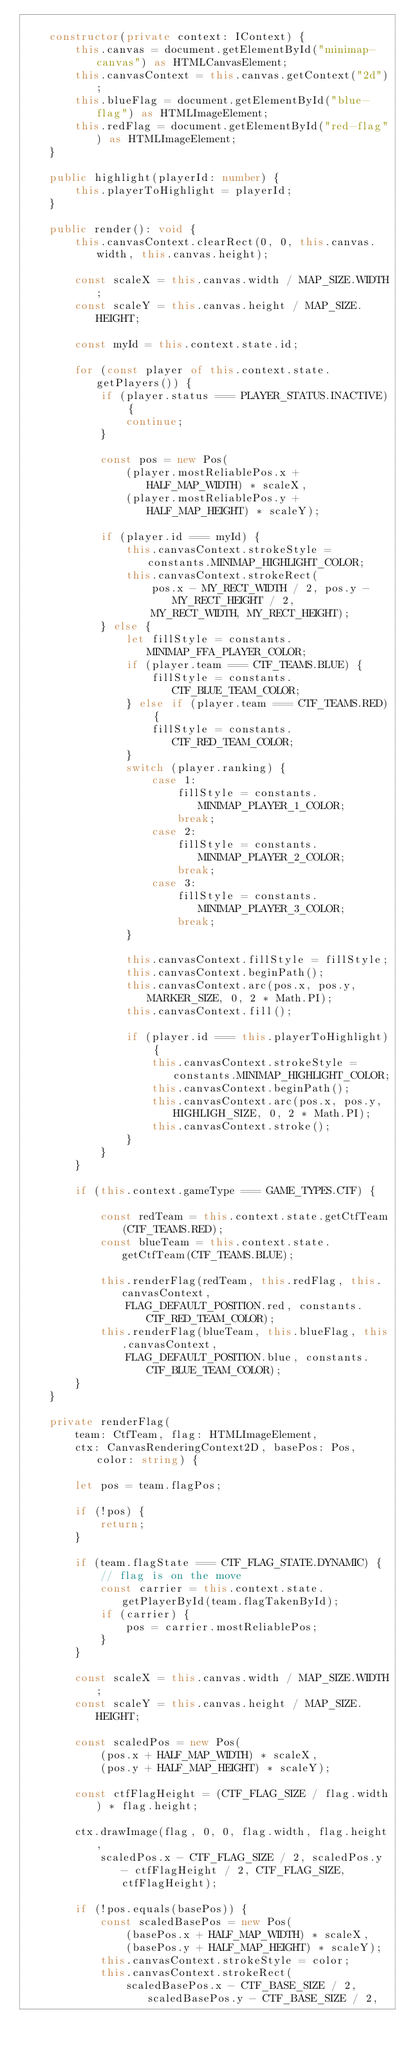Convert code to text. <code><loc_0><loc_0><loc_500><loc_500><_TypeScript_>
    constructor(private context: IContext) {
        this.canvas = document.getElementById("minimap-canvas") as HTMLCanvasElement;
        this.canvasContext = this.canvas.getContext("2d");
        this.blueFlag = document.getElementById("blue-flag") as HTMLImageElement;
        this.redFlag = document.getElementById("red-flag") as HTMLImageElement;
    }

    public highlight(playerId: number) {
        this.playerToHighlight = playerId;
    }

    public render(): void {
        this.canvasContext.clearRect(0, 0, this.canvas.width, this.canvas.height);

        const scaleX = this.canvas.width / MAP_SIZE.WIDTH;
        const scaleY = this.canvas.height / MAP_SIZE.HEIGHT;

        const myId = this.context.state.id;

        for (const player of this.context.state.getPlayers()) {
            if (player.status === PLAYER_STATUS.INACTIVE) {
                continue;
            }

            const pos = new Pos(
                (player.mostReliablePos.x + HALF_MAP_WIDTH) * scaleX,
                (player.mostReliablePos.y + HALF_MAP_HEIGHT) * scaleY);

            if (player.id === myId) {
                this.canvasContext.strokeStyle = constants.MINIMAP_HIGHLIGHT_COLOR;
                this.canvasContext.strokeRect(
                    pos.x - MY_RECT_WIDTH / 2, pos.y - MY_RECT_HEIGHT / 2,
                    MY_RECT_WIDTH, MY_RECT_HEIGHT);
            } else {
                let fillStyle = constants.MINIMAP_FFA_PLAYER_COLOR;
                if (player.team === CTF_TEAMS.BLUE) {
                    fillStyle = constants.CTF_BLUE_TEAM_COLOR;
                } else if (player.team === CTF_TEAMS.RED) {
                    fillStyle = constants.CTF_RED_TEAM_COLOR;
                }
                switch (player.ranking) {
                    case 1:
                        fillStyle = constants.MINIMAP_PLAYER_1_COLOR;
                        break;
                    case 2:
                        fillStyle = constants.MINIMAP_PLAYER_2_COLOR;
                        break;
                    case 3:
                        fillStyle = constants.MINIMAP_PLAYER_3_COLOR;
                        break;
                }

                this.canvasContext.fillStyle = fillStyle;
                this.canvasContext.beginPath();
                this.canvasContext.arc(pos.x, pos.y, MARKER_SIZE, 0, 2 * Math.PI);
                this.canvasContext.fill();

                if (player.id === this.playerToHighlight) {
                    this.canvasContext.strokeStyle = constants.MINIMAP_HIGHLIGHT_COLOR;
                    this.canvasContext.beginPath();
                    this.canvasContext.arc(pos.x, pos.y, HIGHLIGH_SIZE, 0, 2 * Math.PI);
                    this.canvasContext.stroke();
                }
            }
        }

        if (this.context.gameType === GAME_TYPES.CTF) {

            const redTeam = this.context.state.getCtfTeam(CTF_TEAMS.RED);
            const blueTeam = this.context.state.getCtfTeam(CTF_TEAMS.BLUE);

            this.renderFlag(redTeam, this.redFlag, this.canvasContext,
                FLAG_DEFAULT_POSITION.red, constants.CTF_RED_TEAM_COLOR);
            this.renderFlag(blueTeam, this.blueFlag, this.canvasContext,
                FLAG_DEFAULT_POSITION.blue, constants.CTF_BLUE_TEAM_COLOR);
        }
    }

    private renderFlag(
        team: CtfTeam, flag: HTMLImageElement,
        ctx: CanvasRenderingContext2D, basePos: Pos, color: string) {

        let pos = team.flagPos;

        if (!pos) {
            return;
        }

        if (team.flagState === CTF_FLAG_STATE.DYNAMIC) {
            // flag is on the move
            const carrier = this.context.state.getPlayerById(team.flagTakenById);
            if (carrier) {
                pos = carrier.mostReliablePos;
            }
        }

        const scaleX = this.canvas.width / MAP_SIZE.WIDTH;
        const scaleY = this.canvas.height / MAP_SIZE.HEIGHT;

        const scaledPos = new Pos(
            (pos.x + HALF_MAP_WIDTH) * scaleX,
            (pos.y + HALF_MAP_HEIGHT) * scaleY);

        const ctfFlagHeight = (CTF_FLAG_SIZE / flag.width) * flag.height;

        ctx.drawImage(flag, 0, 0, flag.width, flag.height,
            scaledPos.x - CTF_FLAG_SIZE / 2, scaledPos.y - ctfFlagHeight / 2, CTF_FLAG_SIZE, ctfFlagHeight);

        if (!pos.equals(basePos)) {
            const scaledBasePos = new Pos(
                (basePos.x + HALF_MAP_WIDTH) * scaleX,
                (basePos.y + HALF_MAP_HEIGHT) * scaleY);
            this.canvasContext.strokeStyle = color;
            this.canvasContext.strokeRect(
                scaledBasePos.x - CTF_BASE_SIZE / 2, scaledBasePos.y - CTF_BASE_SIZE / 2,</code> 